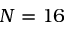<formula> <loc_0><loc_0><loc_500><loc_500>N = 1 6</formula> 